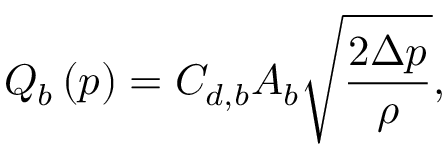<formula> <loc_0><loc_0><loc_500><loc_500>Q _ { b } \left ( p \right ) = C _ { d , b } A _ { b } \sqrt { \frac { 2 \Delta p } { \rho } } ,</formula> 